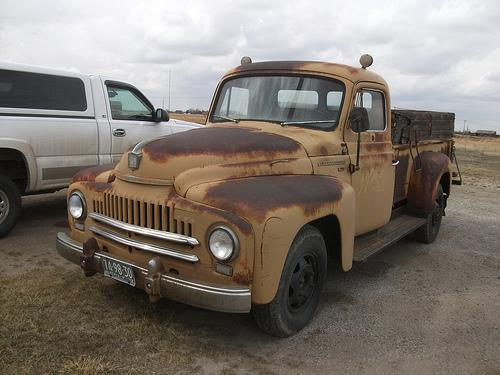Question: what are the head lamps used for?
Choices:
A. Reading.
B. Safety.
C. Seeing the road.
D. Light.
Answer with the letter. Answer: D Question: what kind of vehicle are there?
Choices:
A. Cars.
B. Motorcycles.
C. Scooters.
D. Trucks.
Answer with the letter. Answer: D Question: where are the headlights?
Choices:
A. The front of the truck.
B. On top of the roof.
C. Back of truck.
D. Above the headlights.
Answer with the letter. Answer: A Question: what is the truck used for?
Choices:
A. Hauling things.
B. Transportation.
C. To pull out stumps.
D. Racing.
Answer with the letter. Answer: B Question: how many head lamps are there?
Choices:
A. Four.
B. One.
C. Two.
D. Three.
Answer with the letter. Answer: C 